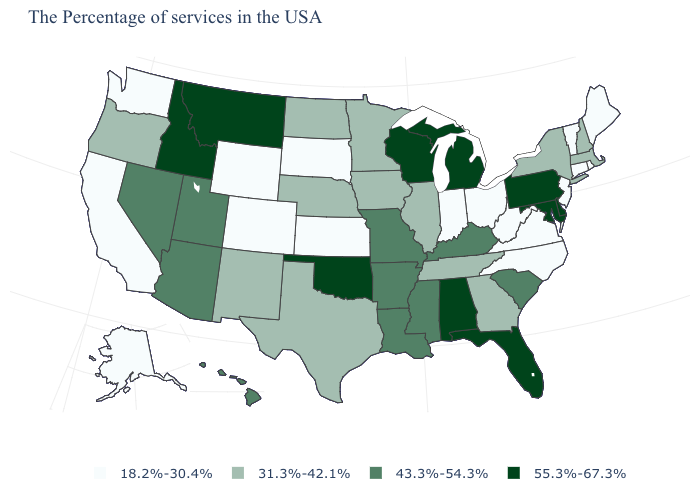Is the legend a continuous bar?
Answer briefly. No. What is the value of Connecticut?
Answer briefly. 18.2%-30.4%. What is the highest value in states that border New Hampshire?
Quick response, please. 31.3%-42.1%. What is the value of Kentucky?
Write a very short answer. 43.3%-54.3%. What is the value of Oklahoma?
Concise answer only. 55.3%-67.3%. Does Maine have a lower value than South Dakota?
Keep it brief. No. Name the states that have a value in the range 31.3%-42.1%?
Answer briefly. Massachusetts, New Hampshire, New York, Georgia, Tennessee, Illinois, Minnesota, Iowa, Nebraska, Texas, North Dakota, New Mexico, Oregon. What is the value of North Dakota?
Quick response, please. 31.3%-42.1%. What is the value of North Carolina?
Answer briefly. 18.2%-30.4%. Does the first symbol in the legend represent the smallest category?
Concise answer only. Yes. Name the states that have a value in the range 18.2%-30.4%?
Be succinct. Maine, Rhode Island, Vermont, Connecticut, New Jersey, Virginia, North Carolina, West Virginia, Ohio, Indiana, Kansas, South Dakota, Wyoming, Colorado, California, Washington, Alaska. Which states hav the highest value in the West?
Give a very brief answer. Montana, Idaho. Which states have the lowest value in the USA?
Quick response, please. Maine, Rhode Island, Vermont, Connecticut, New Jersey, Virginia, North Carolina, West Virginia, Ohio, Indiana, Kansas, South Dakota, Wyoming, Colorado, California, Washington, Alaska. Does Arizona have the highest value in the USA?
Keep it brief. No. Name the states that have a value in the range 55.3%-67.3%?
Short answer required. Delaware, Maryland, Pennsylvania, Florida, Michigan, Alabama, Wisconsin, Oklahoma, Montana, Idaho. 